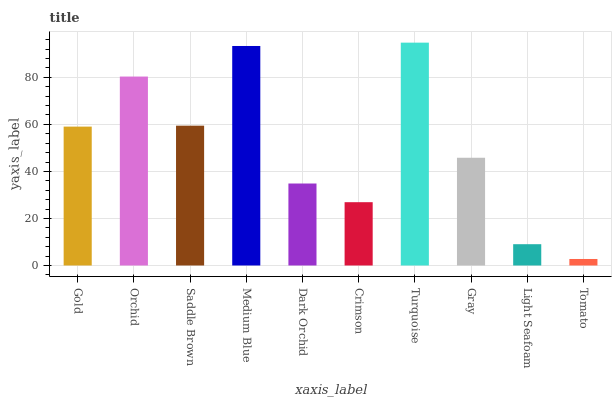Is Tomato the minimum?
Answer yes or no. Yes. Is Turquoise the maximum?
Answer yes or no. Yes. Is Orchid the minimum?
Answer yes or no. No. Is Orchid the maximum?
Answer yes or no. No. Is Orchid greater than Gold?
Answer yes or no. Yes. Is Gold less than Orchid?
Answer yes or no. Yes. Is Gold greater than Orchid?
Answer yes or no. No. Is Orchid less than Gold?
Answer yes or no. No. Is Gold the high median?
Answer yes or no. Yes. Is Gray the low median?
Answer yes or no. Yes. Is Orchid the high median?
Answer yes or no. No. Is Gold the low median?
Answer yes or no. No. 